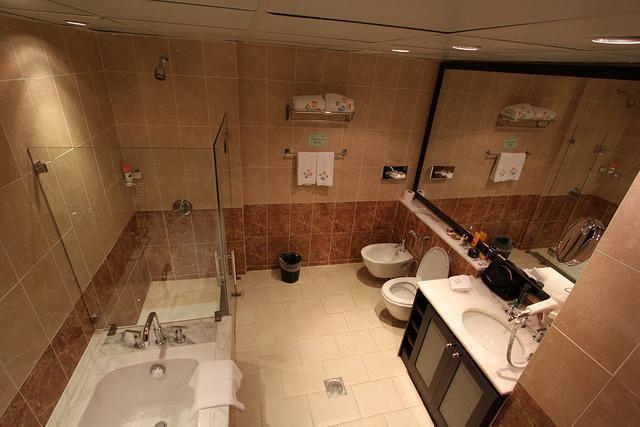What kind of bathroom is this?
Pick the right solution, then justify: 'Answer: answer
Rationale: rationale.'
Options: Home, hotel, hospital, school. Answer: hotel.
Rationale: The bathroom is fancy. 